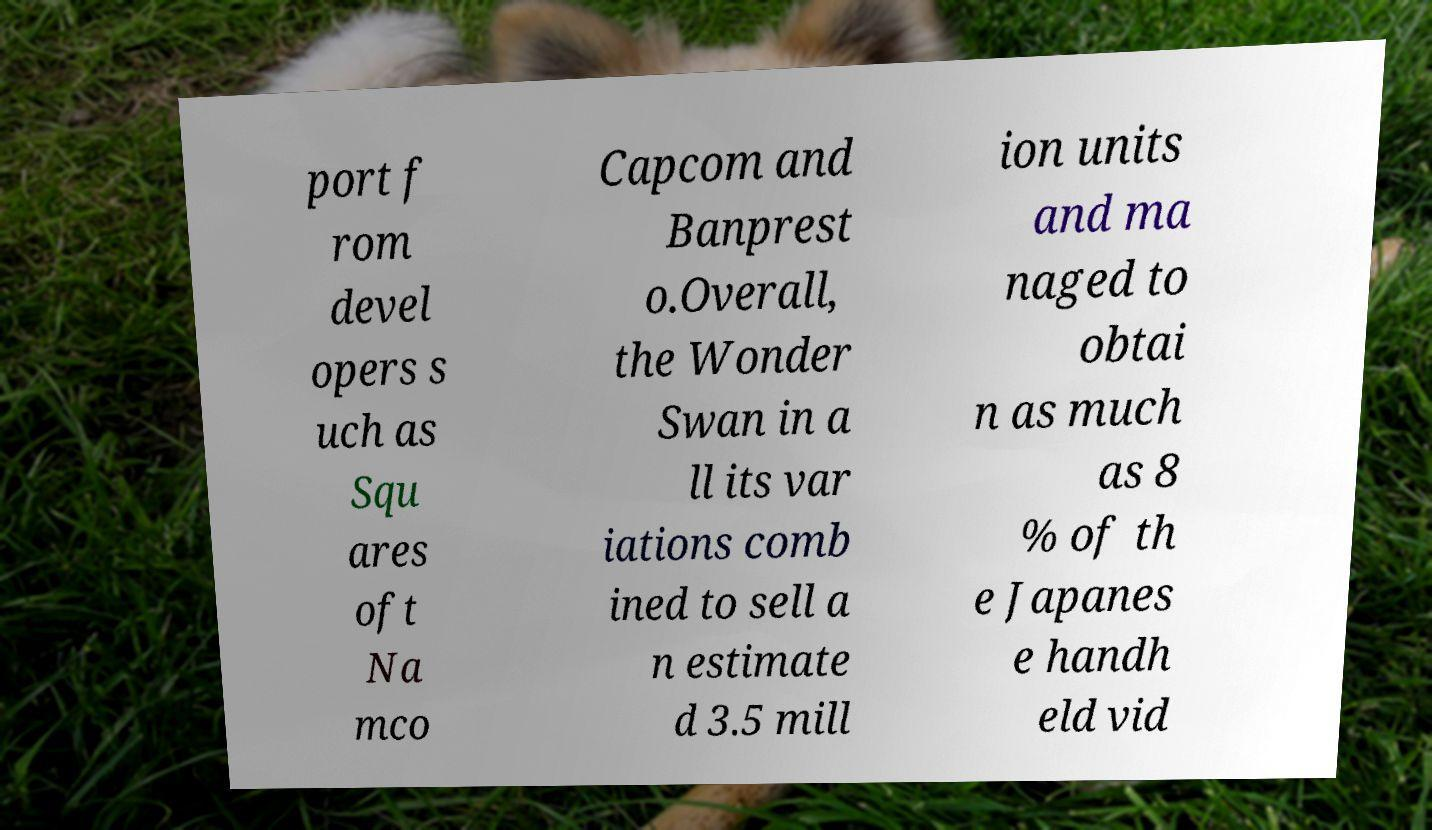What messages or text are displayed in this image? I need them in a readable, typed format. port f rom devel opers s uch as Squ ares oft Na mco Capcom and Banprest o.Overall, the Wonder Swan in a ll its var iations comb ined to sell a n estimate d 3.5 mill ion units and ma naged to obtai n as much as 8 % of th e Japanes e handh eld vid 